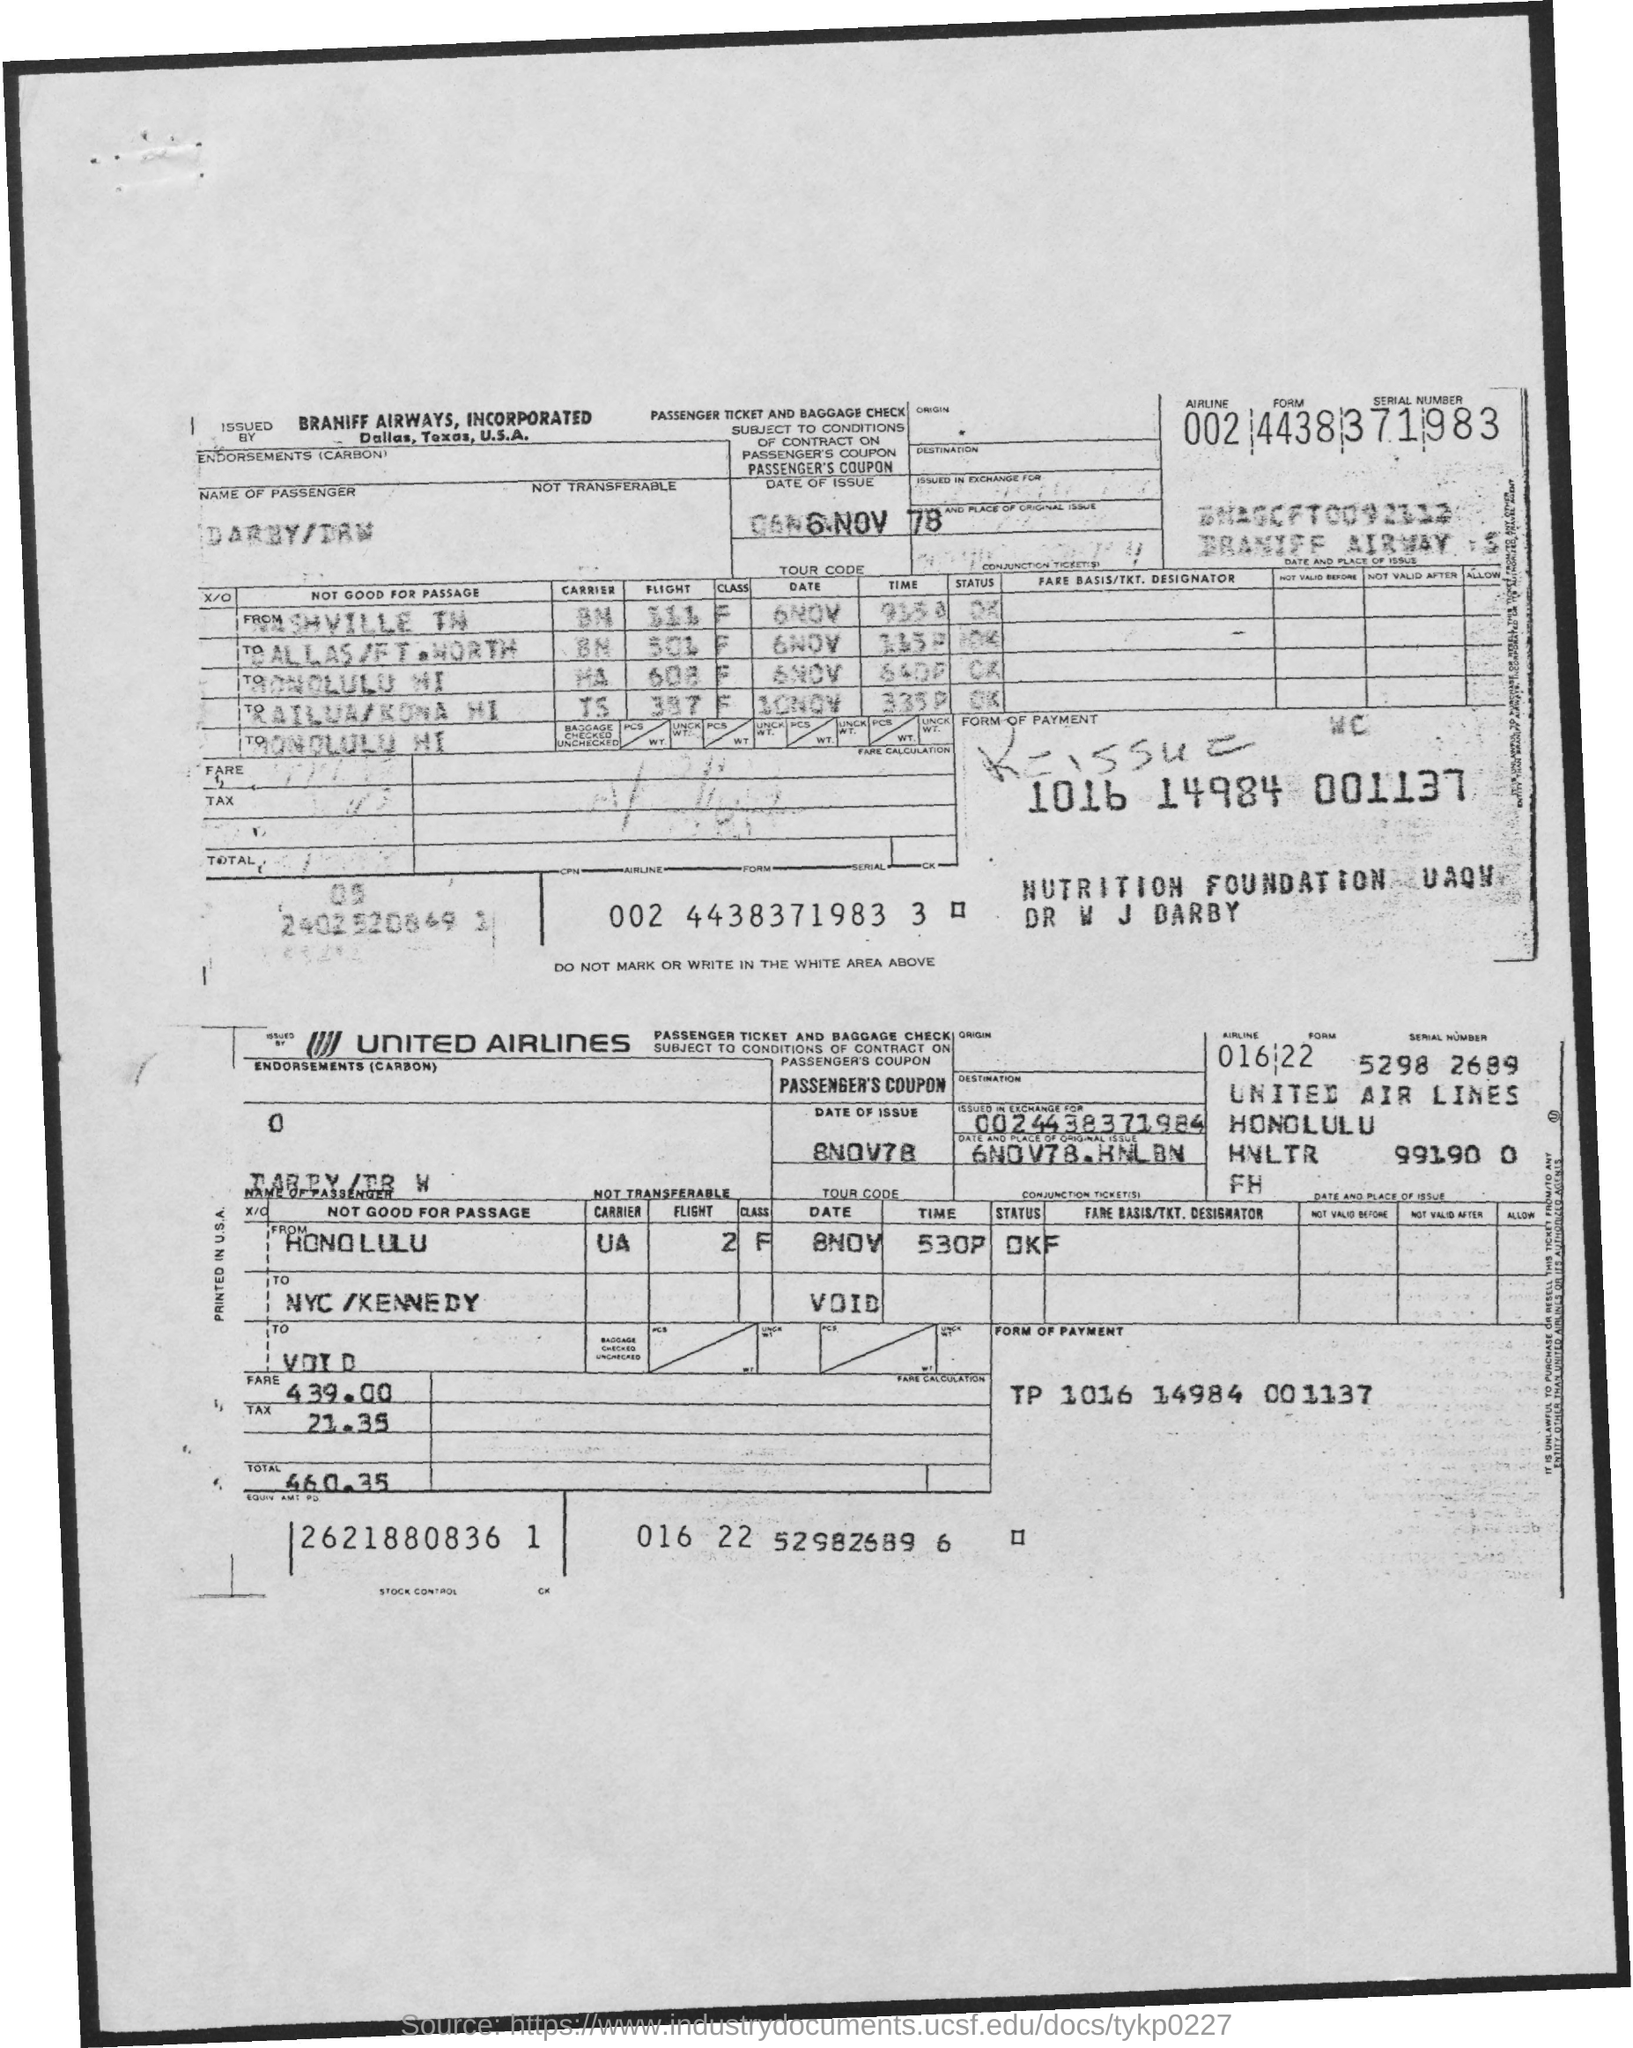It is "issued in exchange for"?
Offer a very short reply. 0024438371984. What is the Date and place of original issue?
Your response must be concise. 6NOV78.HNLBN. What is the Fare?
Offer a very short reply. 439.00. What is the Tax?
Your response must be concise. 21.35. What is the Total?
Your answer should be compact. 460.35. What is the Form of Payment?
Offer a terse response. TP 1016 14984 001137. Which is the Carrier from Honolulu?
Provide a succinct answer. UA. 